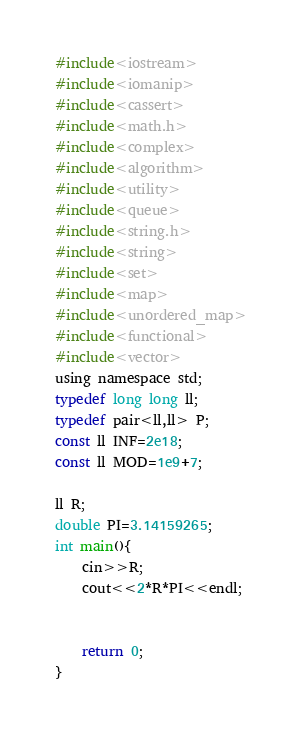<code> <loc_0><loc_0><loc_500><loc_500><_C_>#include<iostream>
#include<iomanip>
#include<cassert>
#include<math.h>
#include<complex>
#include<algorithm>
#include<utility>
#include<queue>
#include<string.h>
#include<string>
#include<set>
#include<map>
#include<unordered_map>
#include<functional>
#include<vector>
using namespace std;
typedef long long ll;
typedef pair<ll,ll> P;
const ll INF=2e18;
const ll MOD=1e9+7;

ll R;
double PI=3.14159265;
int main(){
    cin>>R;
    cout<<2*R*PI<<endl;


    return 0;
}</code> 